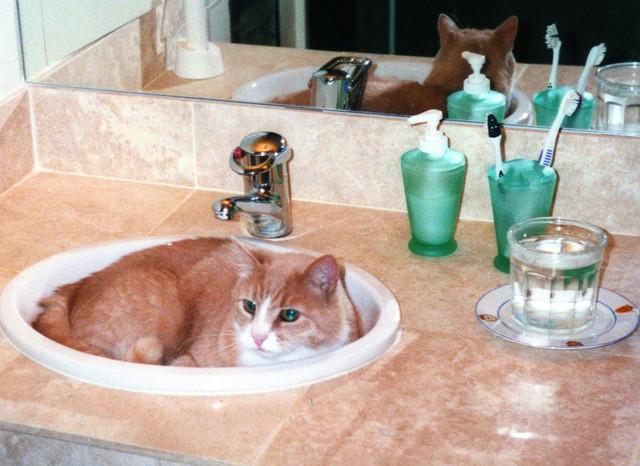How many bottles are visible?
Give a very brief answer. 2. How many cups are there?
Give a very brief answer. 2. 